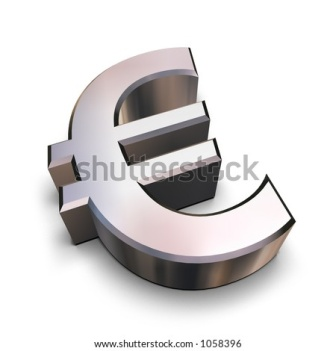Can you describe the significance of the symbol in the image? Certainly! The symbol in the image is the Euro (€), the currency used by the Eurozone countries in the European Union. Introduced in 1999, the Euro is one of the world's most powerful currencies and a symbol of European economic unity and strength. The design of the symbol itself, with its striking simplicity and symmetry, reflects the modern and collective values of the EU. 